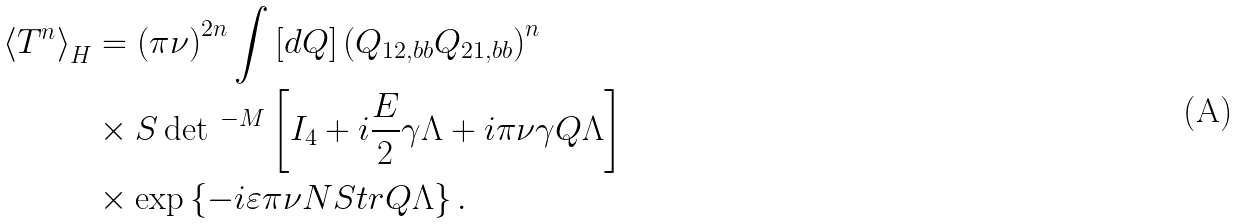Convert formula to latex. <formula><loc_0><loc_0><loc_500><loc_500>\left \langle T ^ { n } \right \rangle _ { H } & = \left ( \pi \nu \right ) ^ { 2 n } \int \left [ d Q \right ] \left ( Q _ { 1 2 , b b } Q _ { 2 1 , b b } \right ) ^ { n } \\ & \times S \det \, ^ { - M } \left [ I _ { 4 } + i \frac { E } { 2 } \gamma \Lambda + i \pi \nu \gamma Q \Lambda \right ] \\ & \times \exp \left \{ - i \varepsilon \pi \nu N S t r Q \Lambda \right \} .</formula> 